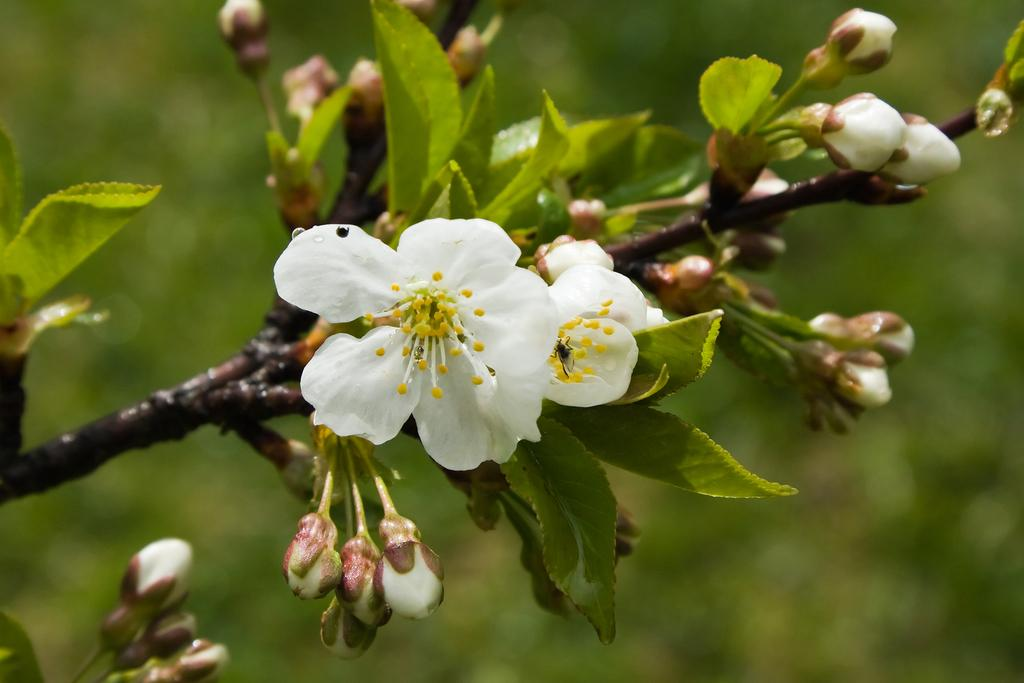What is the main subject of the image? The main subject of the image is a stem. What features can be observed on the stem? The stem has leaves and flower buds. What type of flowers are present on the stem? There are white flowers on the stem. What can be seen in the background of the image? There are plants visible in the background of the image. Can you tell me how many wrens are perched on the stem in the image? There are no wrens present in the image; the main subject is a stem with leaves, flower buds, and white flowers. What type of development is taking place in the jail depicted in the image? There is no jail depicted in the image; the image features a stem with leaves, flower buds, and white flowers. 